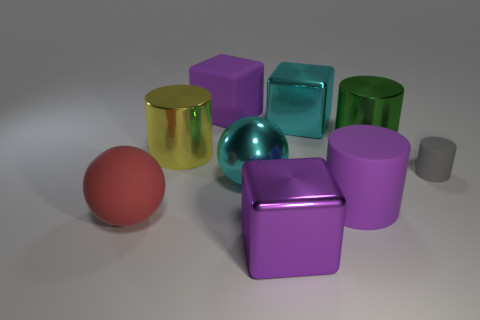I see different shapes in the image, how many cubes are present? In the image, there are a total of three cubes. One is purple, the other is translucent green, and the last one is an opaque, teal color. What colors are dominant in this image? The dominant colors in this image are shades of purple and blue, creating a cool tone overall. The warm golden yellow of one cylinder adds a nice contrast to these cooler shades. 